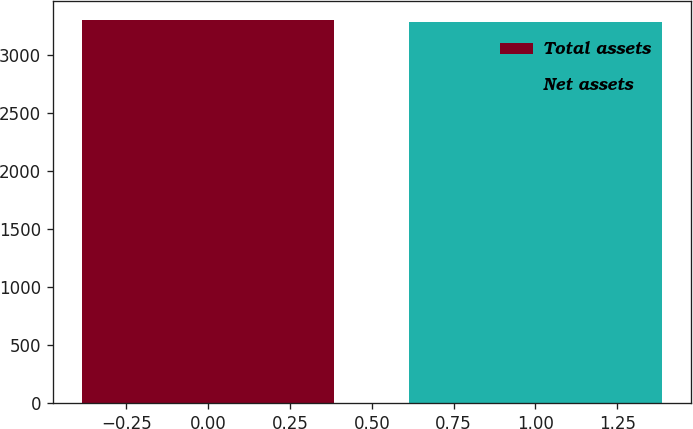Convert chart to OTSL. <chart><loc_0><loc_0><loc_500><loc_500><bar_chart><fcel>Total assets<fcel>Net assets<nl><fcel>3294<fcel>3278<nl></chart> 